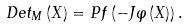Convert formula to latex. <formula><loc_0><loc_0><loc_500><loc_500>D e t _ { M } \left ( X \right ) = P f \left ( - J \varphi \left ( X \right ) \right ) .</formula> 